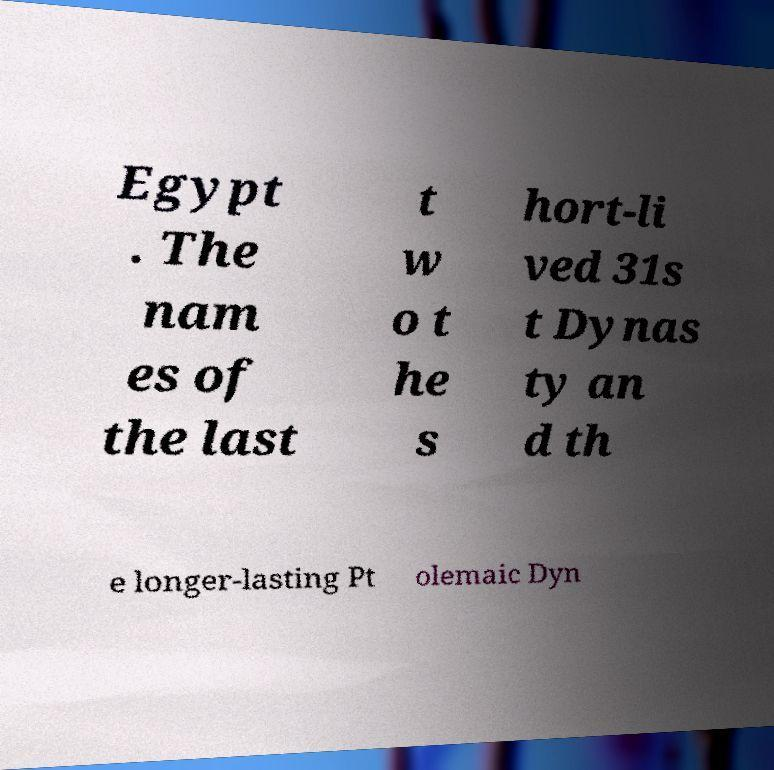Could you assist in decoding the text presented in this image and type it out clearly? Egypt . The nam es of the last t w o t he s hort-li ved 31s t Dynas ty an d th e longer-lasting Pt olemaic Dyn 